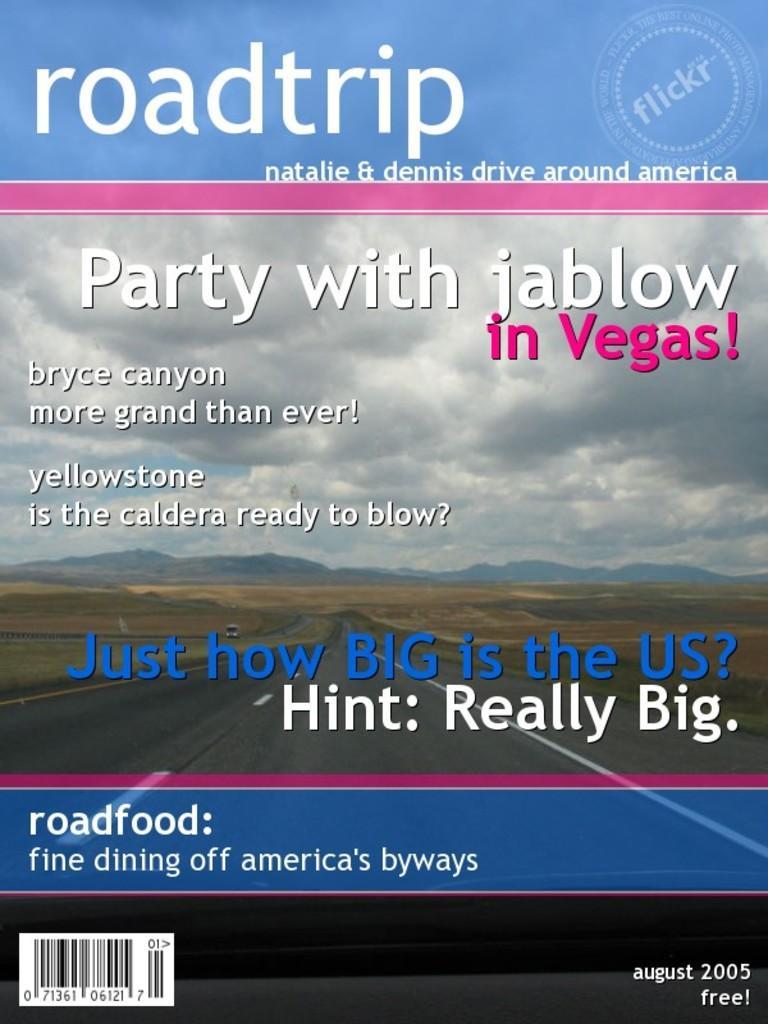Could you give a brief overview of what you see in this image? In this image there is a cover of a book. In the background we can see hills, road, vehicles, sky and clouds. At the top and bottom there is a text. 